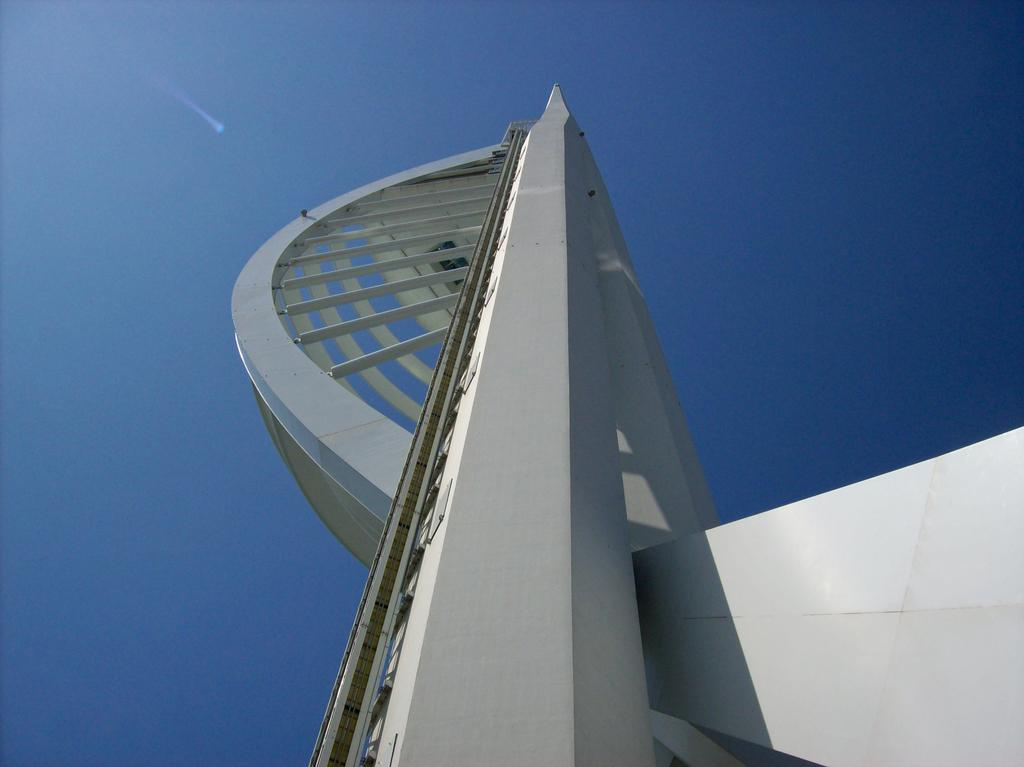What is the main subject of the image? The main subject of the image is an architecture. What can be seen in the background of the image? There is a sky visible in the background of the image. Can you see the face of the sister in the image? There is no face or sister present in the image; it features an architecture and a sky. 